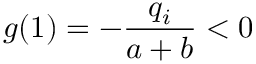<formula> <loc_0><loc_0><loc_500><loc_500>g ( 1 ) = - \frac { q _ { i } } { a + b } < 0</formula> 